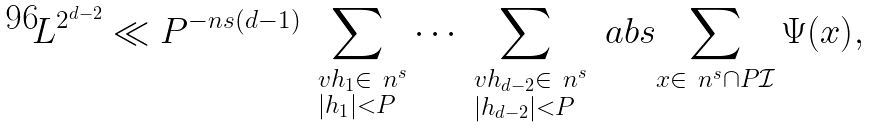Convert formula to latex. <formula><loc_0><loc_0><loc_500><loc_500>L ^ { 2 ^ { d - 2 } } \ll P ^ { - n s ( d - 1 ) } \sum _ { \substack { \ v h _ { 1 } \in \ n ^ { s } \\ | h _ { 1 } | < P } } \cdots \sum _ { \substack { \ v h _ { d - 2 } \in \ n ^ { s } \\ | h _ { d - 2 } | < P } } \ a b s { \sum _ { x \in \ n ^ { s } \cap P \mathcal { I } } \Psi ( x ) } ,</formula> 